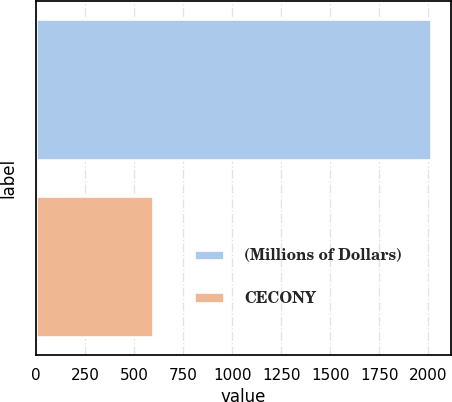Convert chart. <chart><loc_0><loc_0><loc_500><loc_500><bar_chart><fcel>(Millions of Dollars)<fcel>CECONY<nl><fcel>2017<fcel>596<nl></chart> 